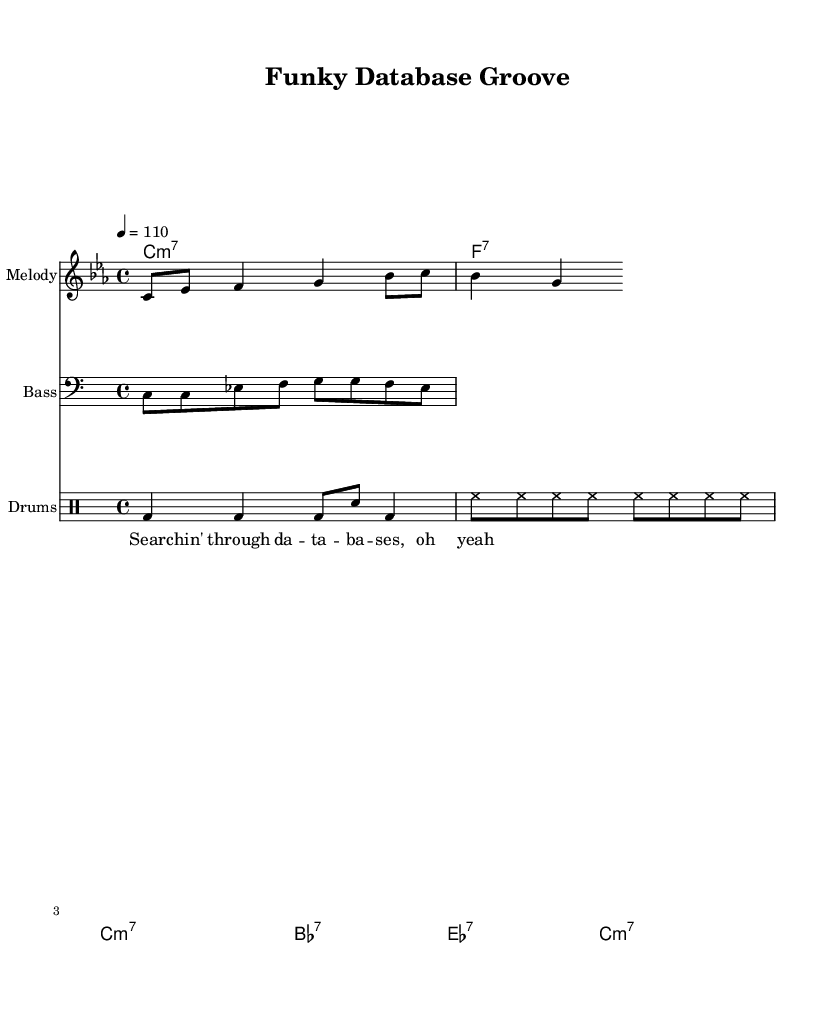What is the key signature of this music? The key signature is C minor, which has three flats. This can be identified by looking at the beginning of the staff where the flat symbols are placed.
Answer: C minor What is the time signature of this music? The time signature is 4/4, which indicates that there are four beats in a measure and that a quarter note receives one beat. This is observed at the start of the sheet music, represented by the "4/4" notation.
Answer: 4/4 What is the tempo marking for this piece? The tempo marking is 110 beats per minute, indicated by the "4 = 110" beneath the tempo section. This shows the desired speed for the music.
Answer: 110 What is the first note of the melody? The first note of the melody is C, which is shown at the beginning of the melody line. It is the first note notated on the staff.
Answer: C How many measures are in the melody? The melody consists of four measures, which can be counted by identifying the measure lines within the staff that separate groups of notes. The melody flows for a total of four complete sections.
Answer: 4 What is the main characteristic of funk music reflected in this piece? The piece demonstrates syncopation and a strong rhythm, which are key features of funk music. This can be inferred from the style of the bassline and drum patterns, where the emphasis tends to land off the primary beats.
Answer: Syncopation 